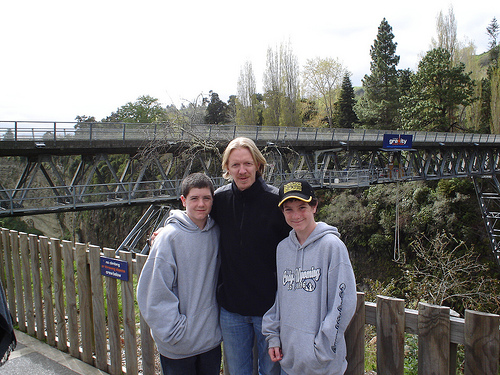<image>
Is the man to the right of the child two? Yes. From this viewpoint, the man is positioned to the right side relative to the child two. 